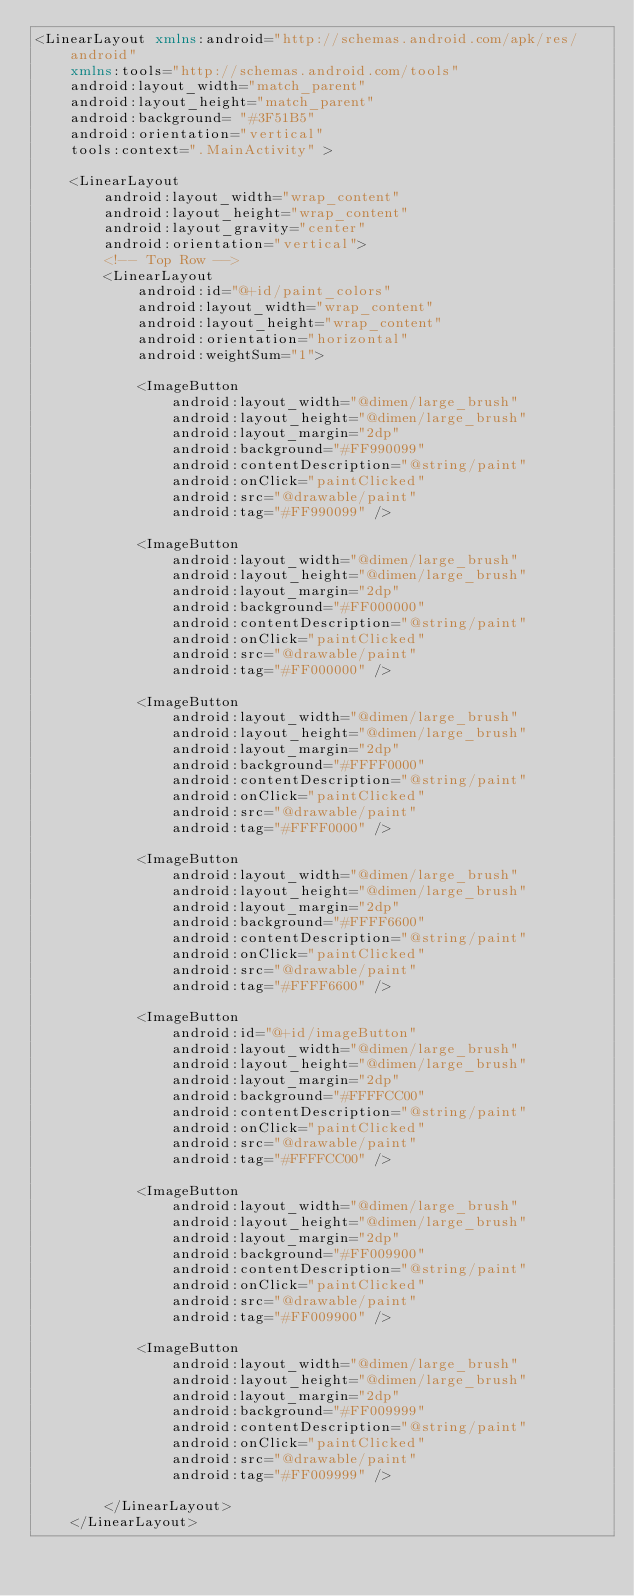Convert code to text. <code><loc_0><loc_0><loc_500><loc_500><_XML_><LinearLayout xmlns:android="http://schemas.android.com/apk/res/android"
    xmlns:tools="http://schemas.android.com/tools"
    android:layout_width="match_parent"
    android:layout_height="match_parent"
    android:background= "#3F51B5"
    android:orientation="vertical"
    tools:context=".MainActivity" >

    <LinearLayout
        android:layout_width="wrap_content"
        android:layout_height="wrap_content"
        android:layout_gravity="center"
        android:orientation="vertical">
        <!-- Top Row -->
        <LinearLayout
            android:id="@+id/paint_colors"
            android:layout_width="wrap_content"
            android:layout_height="wrap_content"
            android:orientation="horizontal"
            android:weightSum="1">

            <ImageButton
                android:layout_width="@dimen/large_brush"
                android:layout_height="@dimen/large_brush"
                android:layout_margin="2dp"
                android:background="#FF990099"
                android:contentDescription="@string/paint"
                android:onClick="paintClicked"
                android:src="@drawable/paint"
                android:tag="#FF990099" />

            <ImageButton
                android:layout_width="@dimen/large_brush"
                android:layout_height="@dimen/large_brush"
                android:layout_margin="2dp"
                android:background="#FF000000"
                android:contentDescription="@string/paint"
                android:onClick="paintClicked"
                android:src="@drawable/paint"
                android:tag="#FF000000" />

            <ImageButton
                android:layout_width="@dimen/large_brush"
                android:layout_height="@dimen/large_brush"
                android:layout_margin="2dp"
                android:background="#FFFF0000"
                android:contentDescription="@string/paint"
                android:onClick="paintClicked"
                android:src="@drawable/paint"
                android:tag="#FFFF0000" />

            <ImageButton
                android:layout_width="@dimen/large_brush"
                android:layout_height="@dimen/large_brush"
                android:layout_margin="2dp"
                android:background="#FFFF6600"
                android:contentDescription="@string/paint"
                android:onClick="paintClicked"
                android:src="@drawable/paint"
                android:tag="#FFFF6600" />

            <ImageButton
                android:id="@+id/imageButton"
                android:layout_width="@dimen/large_brush"
                android:layout_height="@dimen/large_brush"
                android:layout_margin="2dp"
                android:background="#FFFFCC00"
                android:contentDescription="@string/paint"
                android:onClick="paintClicked"
                android:src="@drawable/paint"
                android:tag="#FFFFCC00" />

            <ImageButton
                android:layout_width="@dimen/large_brush"
                android:layout_height="@dimen/large_brush"
                android:layout_margin="2dp"
                android:background="#FF009900"
                android:contentDescription="@string/paint"
                android:onClick="paintClicked"
                android:src="@drawable/paint"
                android:tag="#FF009900" />

            <ImageButton
                android:layout_width="@dimen/large_brush"
                android:layout_height="@dimen/large_brush"
                android:layout_margin="2dp"
                android:background="#FF009999"
                android:contentDescription="@string/paint"
                android:onClick="paintClicked"
                android:src="@drawable/paint"
                android:tag="#FF009999" />

        </LinearLayout>
    </LinearLayout>
</code> 